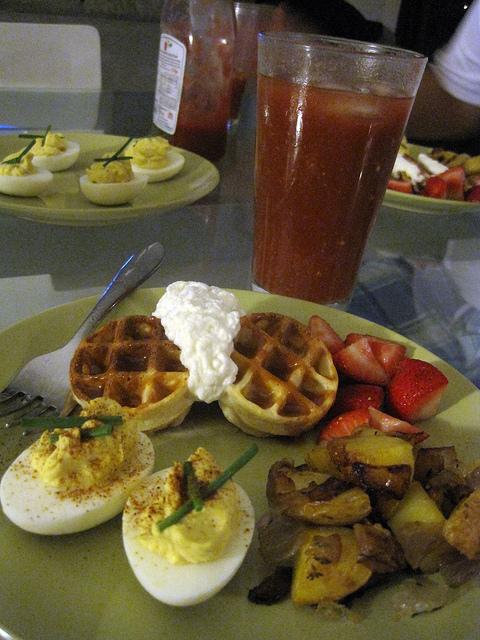Do you see a lemon on the plate?
Answer briefly. No. What is in the bottle in the background?
Quick response, please. Ketchup. What is stuffed inside these eggs?
Concise answer only. Egg. What spice is sprinkled on the deviled eggs?
Be succinct. Paprika. IS there a bike in the picture?
Concise answer only. No. 